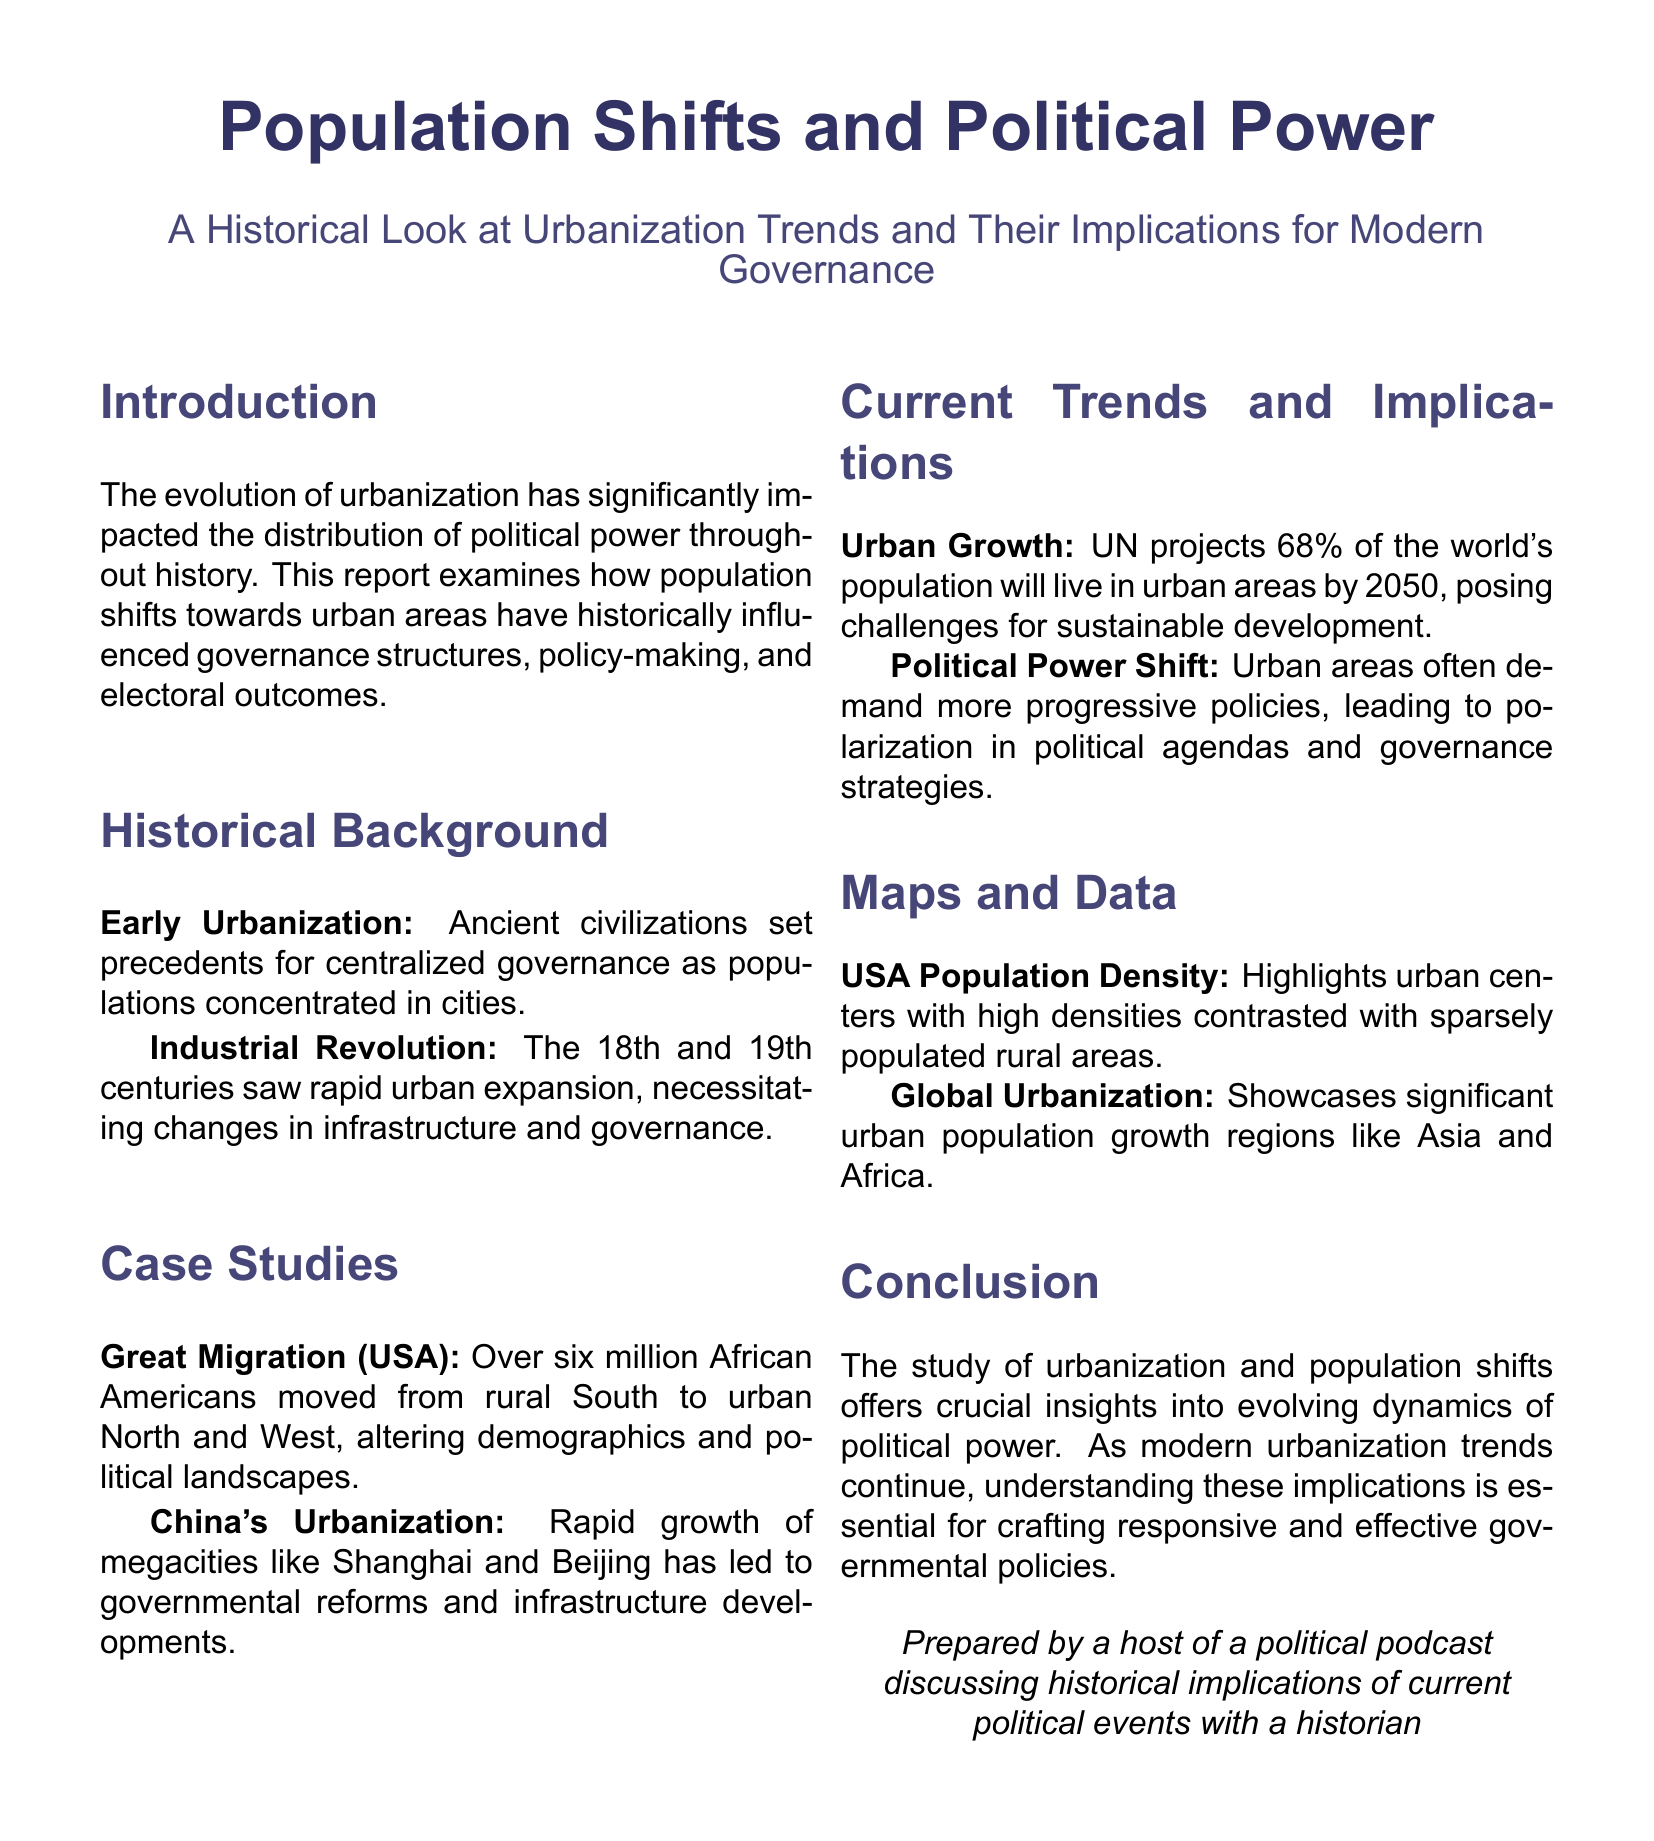What are the projections for the world's urban population by 2050? The UN projects that 68% of the world's population will live in urban areas by 2050.
Answer: 68% What historical event involved over six million African Americans moving to urban areas? This refers to the Great Migration, where over six million African Americans moved from rural South to urban North and West.
Answer: Great Migration What major era initiated rapid urban expansion in the 18th and 19th centuries? The Industrial Revolution marked this period of rapid urban expansion necessitating changes in governance.
Answer: Industrial Revolution Which two Chinese cities are mentioned in relation to urban growth? Shanghai and Beijing are highlighted for their rapid growth and subsequent governmental reforms.
Answer: Shanghai and Beijing What aspect of urban areas often leads to polarization in political agendas? Urban areas often demand more progressive policies, leading to polarization in political agendas.
Answer: Progressive policies What type of maps are discussed in the report? The report includes population density maps showcasing the contrast between urban centers and rural areas.
Answer: Population density maps What implications does urban growth present for sustainable development? Urban growth poses challenges for sustainable development as more people concentrate in urban regions.
Answer: Challenges What was the focus of the document? The focus is on population shifts and their influence on political power throughout history.
Answer: Population shifts and political power 